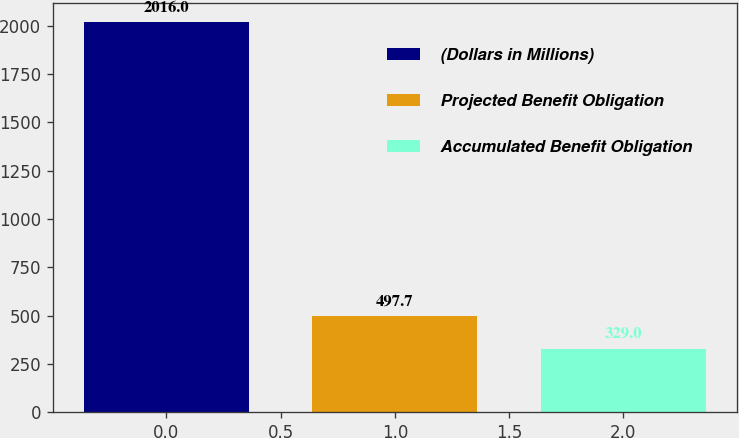<chart> <loc_0><loc_0><loc_500><loc_500><bar_chart><fcel>(Dollars in Millions)<fcel>Projected Benefit Obligation<fcel>Accumulated Benefit Obligation<nl><fcel>2016<fcel>497.7<fcel>329<nl></chart> 